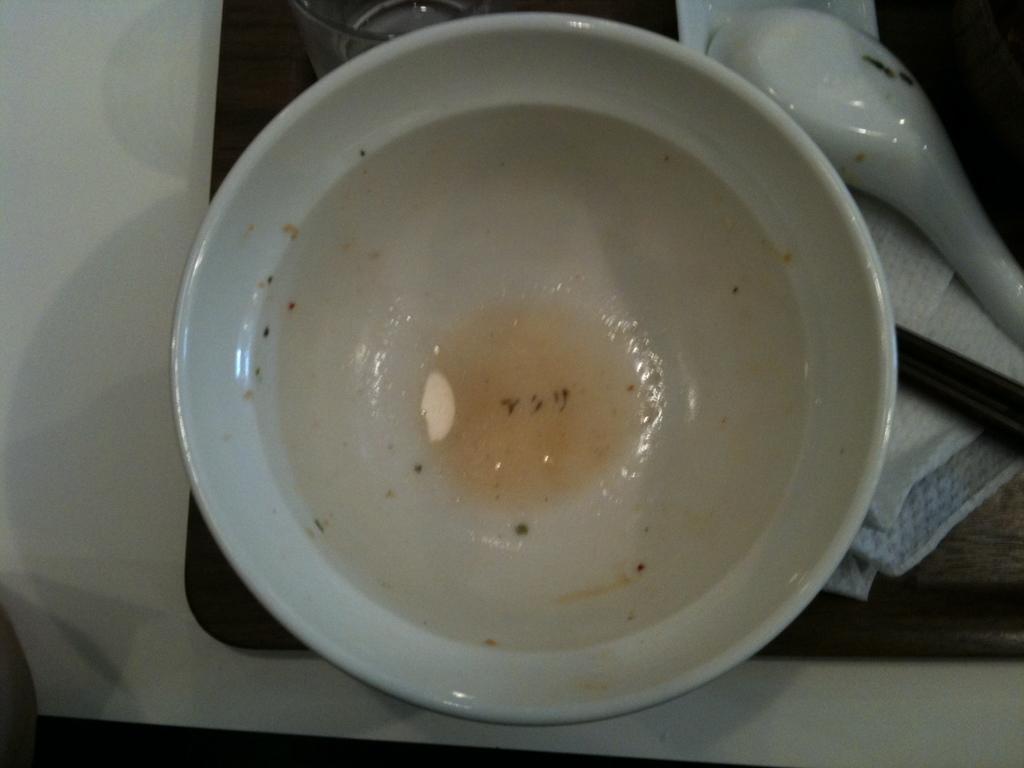Can you describe this image briefly? There is a bowl, spoon and a tissue on a tray in the foreground area of the image. 